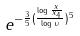<formula> <loc_0><loc_0><loc_500><loc_500>e ^ { - \frac { 3 } { 5 } ( \frac { \log \frac { x } { x _ { 4 } } } { \log \upsilon } ) ^ { 5 } }</formula> 